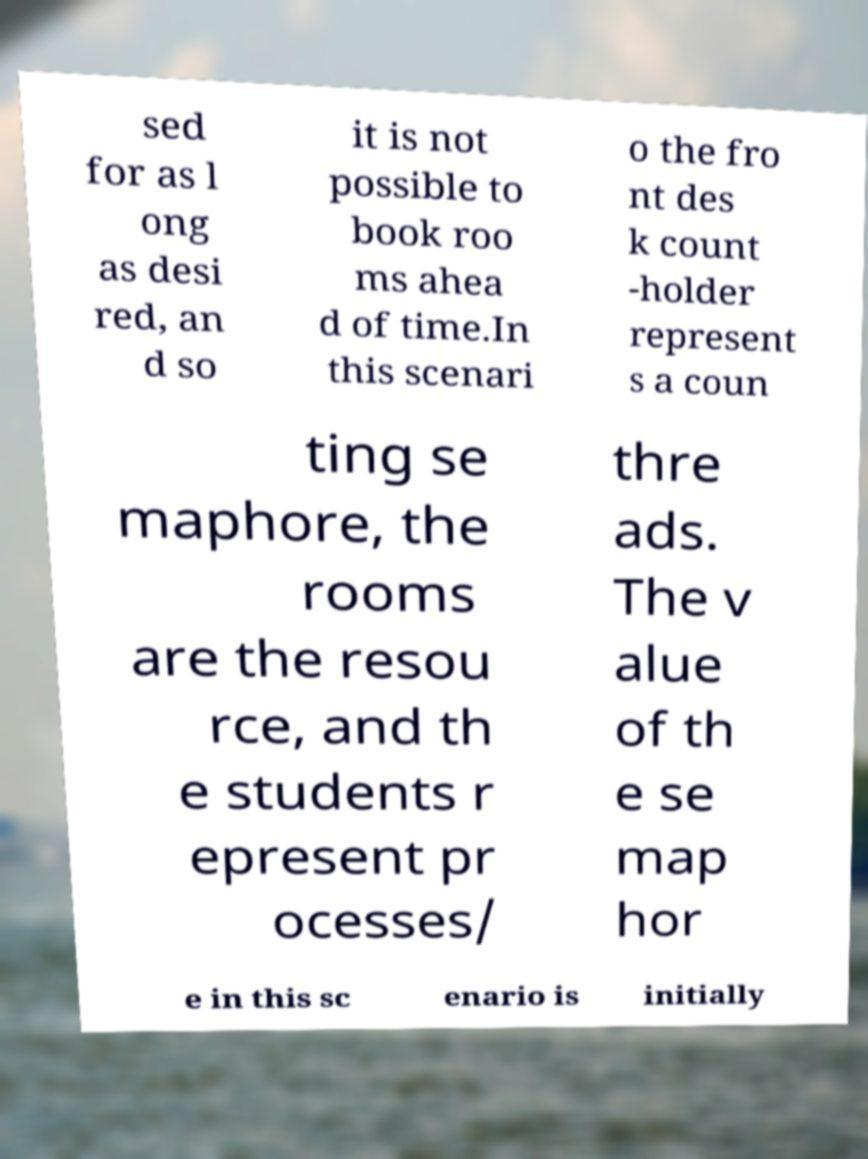I need the written content from this picture converted into text. Can you do that? sed for as l ong as desi red, an d so it is not possible to book roo ms ahea d of time.In this scenari o the fro nt des k count -holder represent s a coun ting se maphore, the rooms are the resou rce, and th e students r epresent pr ocesses/ thre ads. The v alue of th e se map hor e in this sc enario is initially 